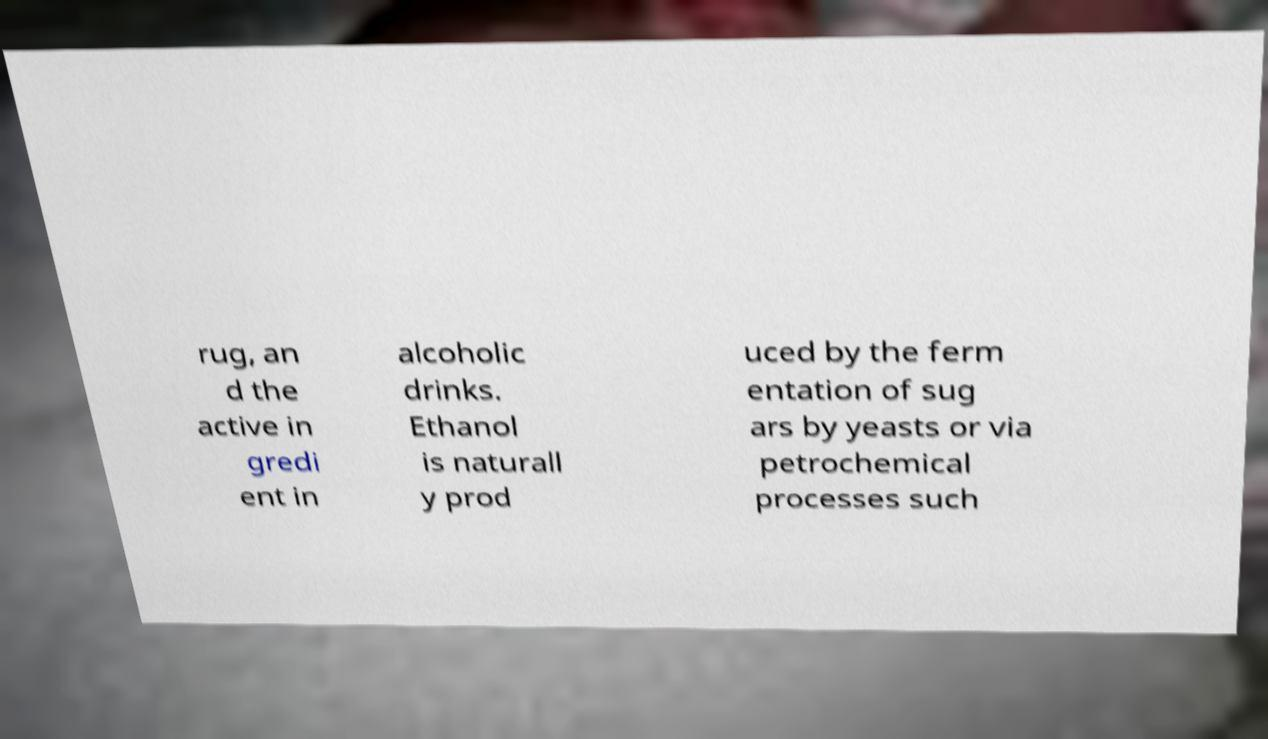Can you read and provide the text displayed in the image?This photo seems to have some interesting text. Can you extract and type it out for me? rug, an d the active in gredi ent in alcoholic drinks. Ethanol is naturall y prod uced by the ferm entation of sug ars by yeasts or via petrochemical processes such 